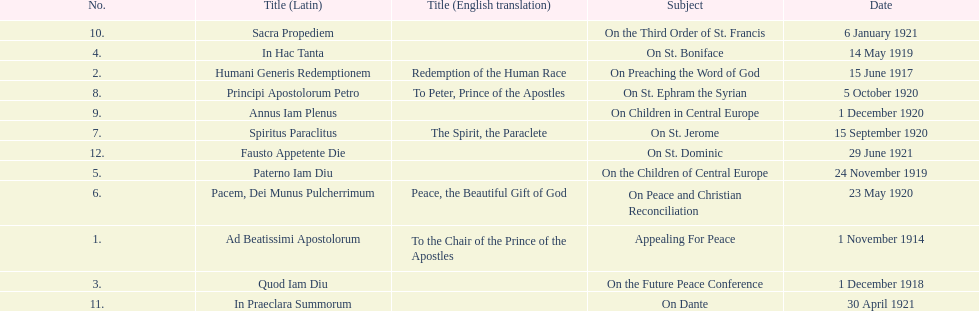How long after quod iam diu was paterno iam diu issued? 11 months. 